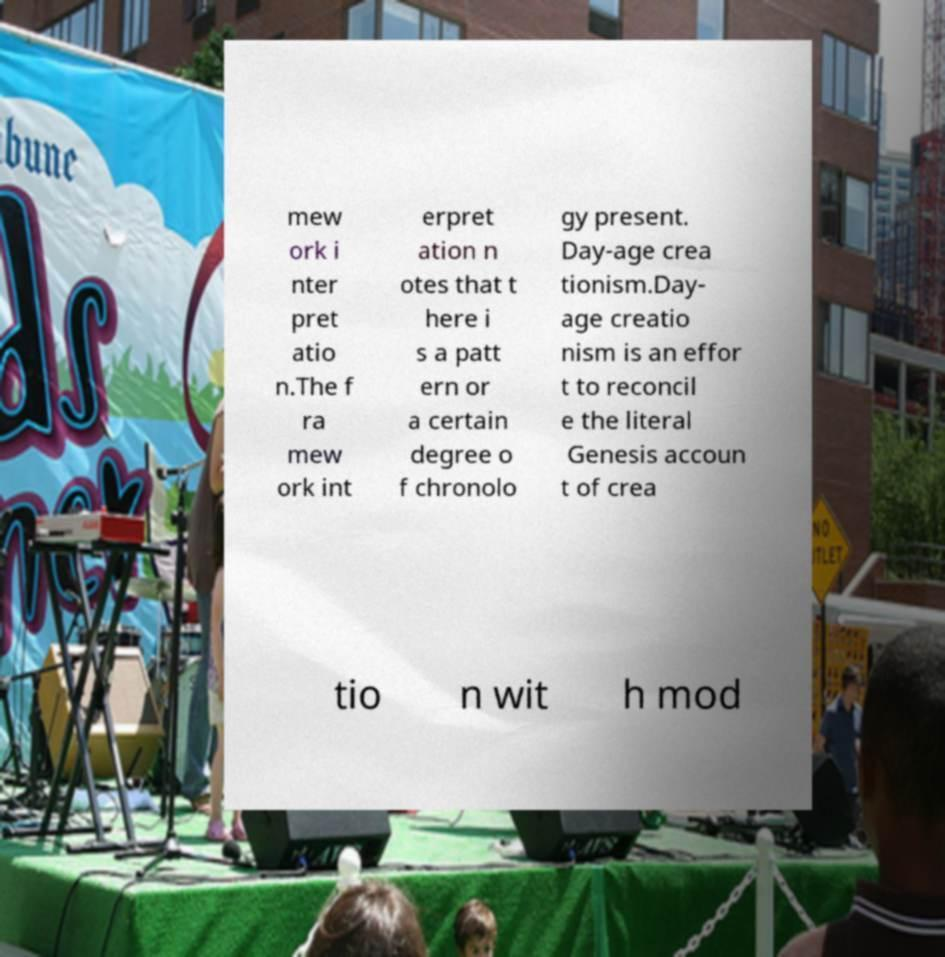Could you extract and type out the text from this image? mew ork i nter pret atio n.The f ra mew ork int erpret ation n otes that t here i s a patt ern or a certain degree o f chronolo gy present. Day-age crea tionism.Day- age creatio nism is an effor t to reconcil e the literal Genesis accoun t of crea tio n wit h mod 